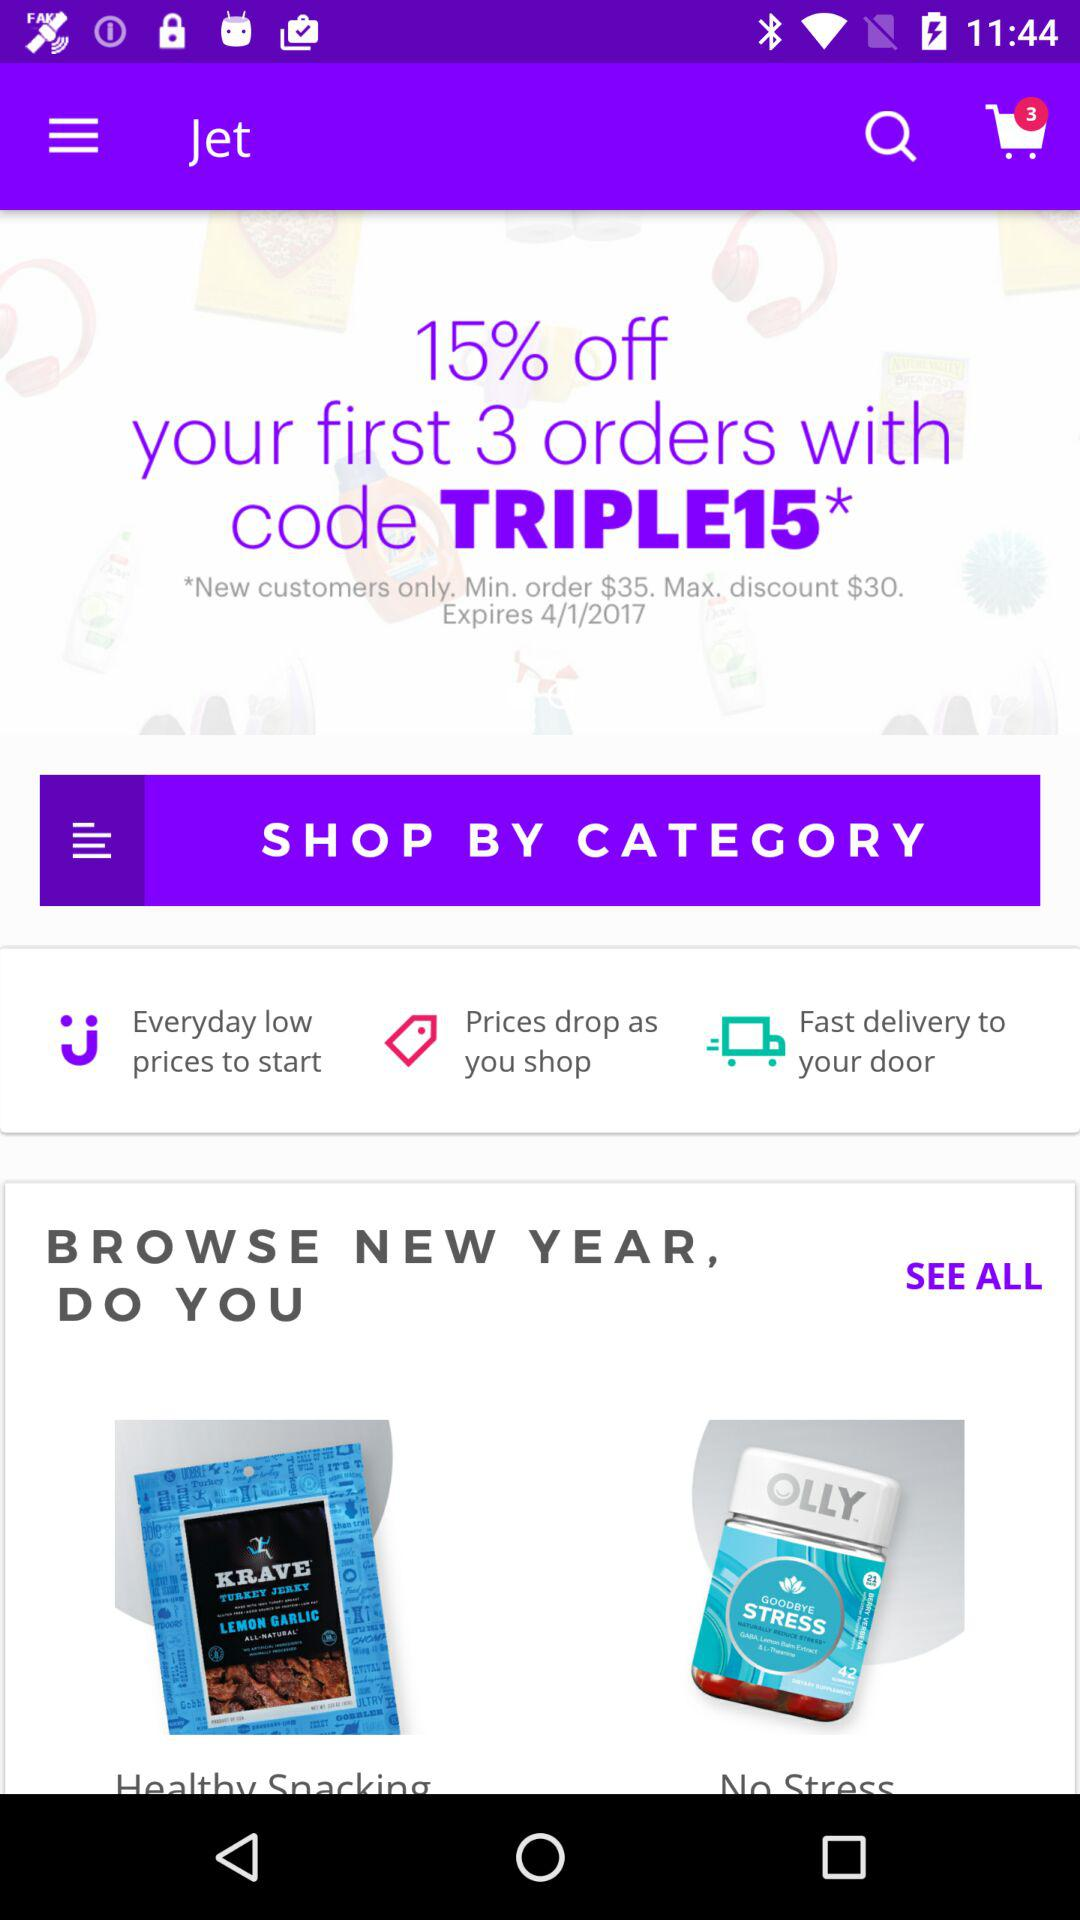What is the discount code? The discount code is "TRIPLE15". 